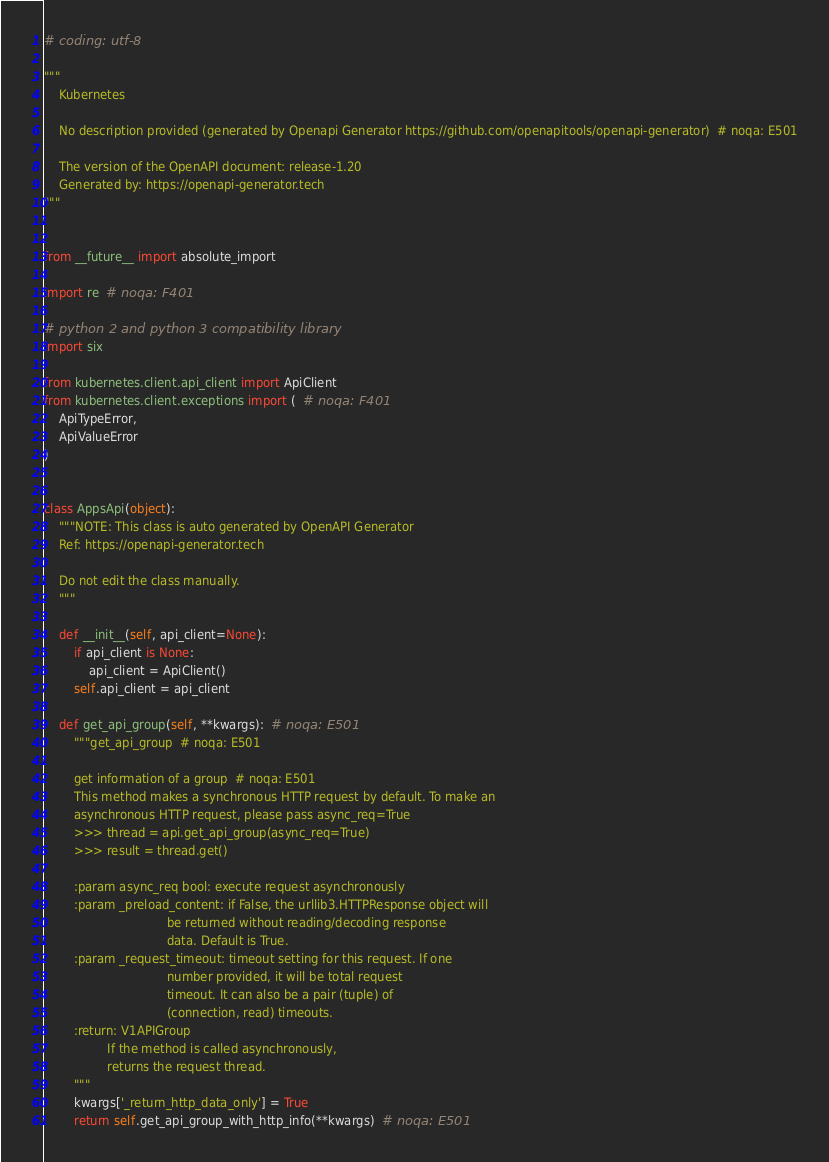Convert code to text. <code><loc_0><loc_0><loc_500><loc_500><_Python_># coding: utf-8

"""
    Kubernetes

    No description provided (generated by Openapi Generator https://github.com/openapitools/openapi-generator)  # noqa: E501

    The version of the OpenAPI document: release-1.20
    Generated by: https://openapi-generator.tech
"""


from __future__ import absolute_import

import re  # noqa: F401

# python 2 and python 3 compatibility library
import six

from kubernetes.client.api_client import ApiClient
from kubernetes.client.exceptions import (  # noqa: F401
    ApiTypeError,
    ApiValueError
)


class AppsApi(object):
    """NOTE: This class is auto generated by OpenAPI Generator
    Ref: https://openapi-generator.tech

    Do not edit the class manually.
    """

    def __init__(self, api_client=None):
        if api_client is None:
            api_client = ApiClient()
        self.api_client = api_client

    def get_api_group(self, **kwargs):  # noqa: E501
        """get_api_group  # noqa: E501

        get information of a group  # noqa: E501
        This method makes a synchronous HTTP request by default. To make an
        asynchronous HTTP request, please pass async_req=True
        >>> thread = api.get_api_group(async_req=True)
        >>> result = thread.get()

        :param async_req bool: execute request asynchronously
        :param _preload_content: if False, the urllib3.HTTPResponse object will
                                 be returned without reading/decoding response
                                 data. Default is True.
        :param _request_timeout: timeout setting for this request. If one
                                 number provided, it will be total request
                                 timeout. It can also be a pair (tuple) of
                                 (connection, read) timeouts.
        :return: V1APIGroup
                 If the method is called asynchronously,
                 returns the request thread.
        """
        kwargs['_return_http_data_only'] = True
        return self.get_api_group_with_http_info(**kwargs)  # noqa: E501
</code> 